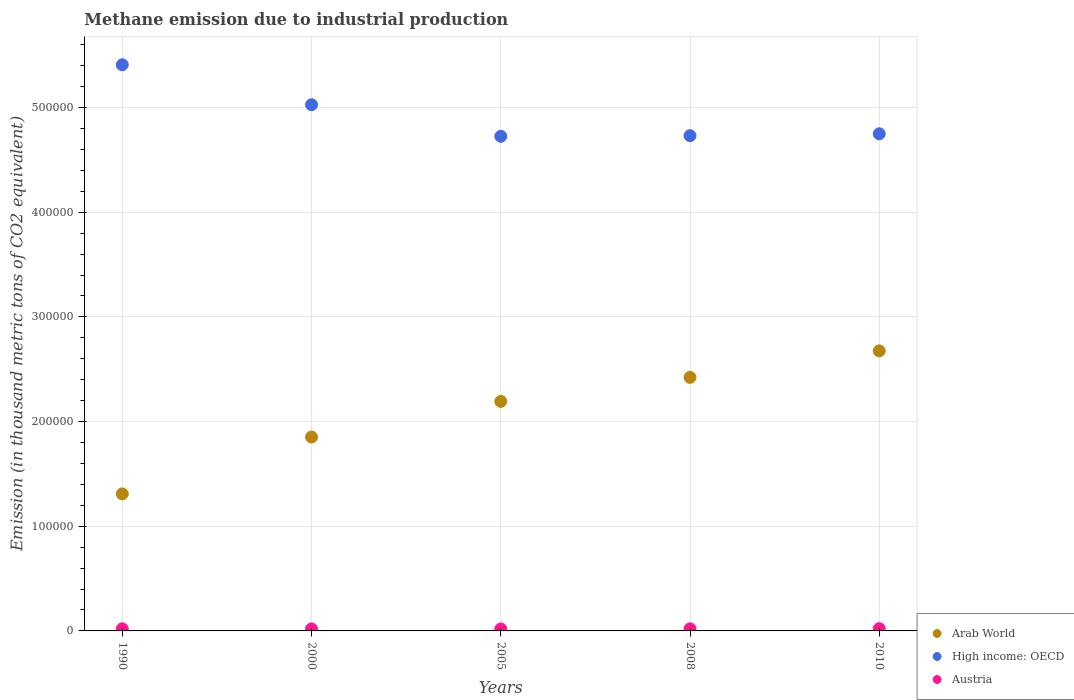How many different coloured dotlines are there?
Make the answer very short. 3. What is the amount of methane emitted in High income: OECD in 2008?
Provide a succinct answer. 4.73e+05. Across all years, what is the maximum amount of methane emitted in Austria?
Give a very brief answer. 2148.9. Across all years, what is the minimum amount of methane emitted in Arab World?
Your response must be concise. 1.31e+05. In which year was the amount of methane emitted in Austria minimum?
Ensure brevity in your answer.  2005. What is the total amount of methane emitted in High income: OECD in the graph?
Your response must be concise. 2.46e+06. What is the difference between the amount of methane emitted in Austria in 1990 and that in 2005?
Offer a very short reply. 182.3. What is the difference between the amount of methane emitted in High income: OECD in 2005 and the amount of methane emitted in Austria in 2008?
Your response must be concise. 4.71e+05. What is the average amount of methane emitted in Arab World per year?
Make the answer very short. 2.09e+05. In the year 2008, what is the difference between the amount of methane emitted in High income: OECD and amount of methane emitted in Arab World?
Ensure brevity in your answer.  2.31e+05. In how many years, is the amount of methane emitted in High income: OECD greater than 60000 thousand metric tons?
Keep it short and to the point. 5. What is the ratio of the amount of methane emitted in Austria in 1990 to that in 2008?
Offer a terse response. 1. Is the difference between the amount of methane emitted in High income: OECD in 1990 and 2008 greater than the difference between the amount of methane emitted in Arab World in 1990 and 2008?
Provide a short and direct response. Yes. What is the difference between the highest and the second highest amount of methane emitted in Austria?
Offer a very short reply. 118.3. What is the difference between the highest and the lowest amount of methane emitted in Austria?
Provide a succinct answer. 300.6. In how many years, is the amount of methane emitted in Arab World greater than the average amount of methane emitted in Arab World taken over all years?
Your response must be concise. 3. Is the sum of the amount of methane emitted in Arab World in 1990 and 2005 greater than the maximum amount of methane emitted in High income: OECD across all years?
Provide a short and direct response. No. Does the amount of methane emitted in High income: OECD monotonically increase over the years?
Provide a succinct answer. No. Is the amount of methane emitted in Arab World strictly greater than the amount of methane emitted in High income: OECD over the years?
Make the answer very short. No. How many dotlines are there?
Provide a succinct answer. 3. What is the difference between two consecutive major ticks on the Y-axis?
Offer a very short reply. 1.00e+05. Are the values on the major ticks of Y-axis written in scientific E-notation?
Provide a succinct answer. No. Does the graph contain any zero values?
Provide a short and direct response. No. Where does the legend appear in the graph?
Provide a short and direct response. Bottom right. How are the legend labels stacked?
Your answer should be compact. Vertical. What is the title of the graph?
Ensure brevity in your answer.  Methane emission due to industrial production. What is the label or title of the Y-axis?
Offer a terse response. Emission (in thousand metric tons of CO2 equivalent). What is the Emission (in thousand metric tons of CO2 equivalent) of Arab World in 1990?
Offer a very short reply. 1.31e+05. What is the Emission (in thousand metric tons of CO2 equivalent) in High income: OECD in 1990?
Ensure brevity in your answer.  5.41e+05. What is the Emission (in thousand metric tons of CO2 equivalent) in Austria in 1990?
Keep it short and to the point. 2030.6. What is the Emission (in thousand metric tons of CO2 equivalent) in Arab World in 2000?
Make the answer very short. 1.85e+05. What is the Emission (in thousand metric tons of CO2 equivalent) of High income: OECD in 2000?
Offer a terse response. 5.03e+05. What is the Emission (in thousand metric tons of CO2 equivalent) of Austria in 2000?
Offer a terse response. 1944.7. What is the Emission (in thousand metric tons of CO2 equivalent) of Arab World in 2005?
Offer a terse response. 2.19e+05. What is the Emission (in thousand metric tons of CO2 equivalent) in High income: OECD in 2005?
Provide a succinct answer. 4.73e+05. What is the Emission (in thousand metric tons of CO2 equivalent) in Austria in 2005?
Offer a very short reply. 1848.3. What is the Emission (in thousand metric tons of CO2 equivalent) in Arab World in 2008?
Ensure brevity in your answer.  2.42e+05. What is the Emission (in thousand metric tons of CO2 equivalent) in High income: OECD in 2008?
Your response must be concise. 4.73e+05. What is the Emission (in thousand metric tons of CO2 equivalent) of Austria in 2008?
Keep it short and to the point. 2025.8. What is the Emission (in thousand metric tons of CO2 equivalent) of Arab World in 2010?
Provide a succinct answer. 2.68e+05. What is the Emission (in thousand metric tons of CO2 equivalent) in High income: OECD in 2010?
Offer a very short reply. 4.75e+05. What is the Emission (in thousand metric tons of CO2 equivalent) in Austria in 2010?
Keep it short and to the point. 2148.9. Across all years, what is the maximum Emission (in thousand metric tons of CO2 equivalent) in Arab World?
Offer a terse response. 2.68e+05. Across all years, what is the maximum Emission (in thousand metric tons of CO2 equivalent) of High income: OECD?
Provide a short and direct response. 5.41e+05. Across all years, what is the maximum Emission (in thousand metric tons of CO2 equivalent) of Austria?
Your answer should be compact. 2148.9. Across all years, what is the minimum Emission (in thousand metric tons of CO2 equivalent) of Arab World?
Offer a terse response. 1.31e+05. Across all years, what is the minimum Emission (in thousand metric tons of CO2 equivalent) of High income: OECD?
Ensure brevity in your answer.  4.73e+05. Across all years, what is the minimum Emission (in thousand metric tons of CO2 equivalent) in Austria?
Offer a very short reply. 1848.3. What is the total Emission (in thousand metric tons of CO2 equivalent) of Arab World in the graph?
Your response must be concise. 1.05e+06. What is the total Emission (in thousand metric tons of CO2 equivalent) in High income: OECD in the graph?
Ensure brevity in your answer.  2.46e+06. What is the total Emission (in thousand metric tons of CO2 equivalent) of Austria in the graph?
Keep it short and to the point. 9998.3. What is the difference between the Emission (in thousand metric tons of CO2 equivalent) in Arab World in 1990 and that in 2000?
Give a very brief answer. -5.43e+04. What is the difference between the Emission (in thousand metric tons of CO2 equivalent) of High income: OECD in 1990 and that in 2000?
Give a very brief answer. 3.82e+04. What is the difference between the Emission (in thousand metric tons of CO2 equivalent) in Austria in 1990 and that in 2000?
Make the answer very short. 85.9. What is the difference between the Emission (in thousand metric tons of CO2 equivalent) in Arab World in 1990 and that in 2005?
Make the answer very short. -8.84e+04. What is the difference between the Emission (in thousand metric tons of CO2 equivalent) in High income: OECD in 1990 and that in 2005?
Offer a terse response. 6.83e+04. What is the difference between the Emission (in thousand metric tons of CO2 equivalent) in Austria in 1990 and that in 2005?
Your answer should be compact. 182.3. What is the difference between the Emission (in thousand metric tons of CO2 equivalent) of Arab World in 1990 and that in 2008?
Offer a terse response. -1.11e+05. What is the difference between the Emission (in thousand metric tons of CO2 equivalent) in High income: OECD in 1990 and that in 2008?
Ensure brevity in your answer.  6.77e+04. What is the difference between the Emission (in thousand metric tons of CO2 equivalent) of Austria in 1990 and that in 2008?
Your answer should be very brief. 4.8. What is the difference between the Emission (in thousand metric tons of CO2 equivalent) of Arab World in 1990 and that in 2010?
Give a very brief answer. -1.37e+05. What is the difference between the Emission (in thousand metric tons of CO2 equivalent) in High income: OECD in 1990 and that in 2010?
Offer a terse response. 6.59e+04. What is the difference between the Emission (in thousand metric tons of CO2 equivalent) of Austria in 1990 and that in 2010?
Ensure brevity in your answer.  -118.3. What is the difference between the Emission (in thousand metric tons of CO2 equivalent) of Arab World in 2000 and that in 2005?
Offer a very short reply. -3.41e+04. What is the difference between the Emission (in thousand metric tons of CO2 equivalent) of High income: OECD in 2000 and that in 2005?
Make the answer very short. 3.02e+04. What is the difference between the Emission (in thousand metric tons of CO2 equivalent) of Austria in 2000 and that in 2005?
Give a very brief answer. 96.4. What is the difference between the Emission (in thousand metric tons of CO2 equivalent) of Arab World in 2000 and that in 2008?
Keep it short and to the point. -5.70e+04. What is the difference between the Emission (in thousand metric tons of CO2 equivalent) in High income: OECD in 2000 and that in 2008?
Make the answer very short. 2.96e+04. What is the difference between the Emission (in thousand metric tons of CO2 equivalent) in Austria in 2000 and that in 2008?
Give a very brief answer. -81.1. What is the difference between the Emission (in thousand metric tons of CO2 equivalent) of Arab World in 2000 and that in 2010?
Ensure brevity in your answer.  -8.23e+04. What is the difference between the Emission (in thousand metric tons of CO2 equivalent) in High income: OECD in 2000 and that in 2010?
Keep it short and to the point. 2.78e+04. What is the difference between the Emission (in thousand metric tons of CO2 equivalent) in Austria in 2000 and that in 2010?
Your response must be concise. -204.2. What is the difference between the Emission (in thousand metric tons of CO2 equivalent) of Arab World in 2005 and that in 2008?
Your response must be concise. -2.29e+04. What is the difference between the Emission (in thousand metric tons of CO2 equivalent) of High income: OECD in 2005 and that in 2008?
Ensure brevity in your answer.  -593. What is the difference between the Emission (in thousand metric tons of CO2 equivalent) of Austria in 2005 and that in 2008?
Offer a very short reply. -177.5. What is the difference between the Emission (in thousand metric tons of CO2 equivalent) in Arab World in 2005 and that in 2010?
Your answer should be very brief. -4.82e+04. What is the difference between the Emission (in thousand metric tons of CO2 equivalent) of High income: OECD in 2005 and that in 2010?
Your answer should be very brief. -2407.6. What is the difference between the Emission (in thousand metric tons of CO2 equivalent) of Austria in 2005 and that in 2010?
Your answer should be very brief. -300.6. What is the difference between the Emission (in thousand metric tons of CO2 equivalent) in Arab World in 2008 and that in 2010?
Make the answer very short. -2.53e+04. What is the difference between the Emission (in thousand metric tons of CO2 equivalent) of High income: OECD in 2008 and that in 2010?
Give a very brief answer. -1814.6. What is the difference between the Emission (in thousand metric tons of CO2 equivalent) in Austria in 2008 and that in 2010?
Keep it short and to the point. -123.1. What is the difference between the Emission (in thousand metric tons of CO2 equivalent) in Arab World in 1990 and the Emission (in thousand metric tons of CO2 equivalent) in High income: OECD in 2000?
Offer a very short reply. -3.72e+05. What is the difference between the Emission (in thousand metric tons of CO2 equivalent) of Arab World in 1990 and the Emission (in thousand metric tons of CO2 equivalent) of Austria in 2000?
Offer a terse response. 1.29e+05. What is the difference between the Emission (in thousand metric tons of CO2 equivalent) in High income: OECD in 1990 and the Emission (in thousand metric tons of CO2 equivalent) in Austria in 2000?
Your answer should be compact. 5.39e+05. What is the difference between the Emission (in thousand metric tons of CO2 equivalent) in Arab World in 1990 and the Emission (in thousand metric tons of CO2 equivalent) in High income: OECD in 2005?
Your answer should be very brief. -3.42e+05. What is the difference between the Emission (in thousand metric tons of CO2 equivalent) in Arab World in 1990 and the Emission (in thousand metric tons of CO2 equivalent) in Austria in 2005?
Keep it short and to the point. 1.29e+05. What is the difference between the Emission (in thousand metric tons of CO2 equivalent) of High income: OECD in 1990 and the Emission (in thousand metric tons of CO2 equivalent) of Austria in 2005?
Your answer should be very brief. 5.39e+05. What is the difference between the Emission (in thousand metric tons of CO2 equivalent) in Arab World in 1990 and the Emission (in thousand metric tons of CO2 equivalent) in High income: OECD in 2008?
Ensure brevity in your answer.  -3.42e+05. What is the difference between the Emission (in thousand metric tons of CO2 equivalent) of Arab World in 1990 and the Emission (in thousand metric tons of CO2 equivalent) of Austria in 2008?
Offer a terse response. 1.29e+05. What is the difference between the Emission (in thousand metric tons of CO2 equivalent) of High income: OECD in 1990 and the Emission (in thousand metric tons of CO2 equivalent) of Austria in 2008?
Make the answer very short. 5.39e+05. What is the difference between the Emission (in thousand metric tons of CO2 equivalent) in Arab World in 1990 and the Emission (in thousand metric tons of CO2 equivalent) in High income: OECD in 2010?
Your answer should be compact. -3.44e+05. What is the difference between the Emission (in thousand metric tons of CO2 equivalent) in Arab World in 1990 and the Emission (in thousand metric tons of CO2 equivalent) in Austria in 2010?
Offer a terse response. 1.29e+05. What is the difference between the Emission (in thousand metric tons of CO2 equivalent) of High income: OECD in 1990 and the Emission (in thousand metric tons of CO2 equivalent) of Austria in 2010?
Offer a very short reply. 5.39e+05. What is the difference between the Emission (in thousand metric tons of CO2 equivalent) of Arab World in 2000 and the Emission (in thousand metric tons of CO2 equivalent) of High income: OECD in 2005?
Provide a short and direct response. -2.87e+05. What is the difference between the Emission (in thousand metric tons of CO2 equivalent) of Arab World in 2000 and the Emission (in thousand metric tons of CO2 equivalent) of Austria in 2005?
Give a very brief answer. 1.83e+05. What is the difference between the Emission (in thousand metric tons of CO2 equivalent) of High income: OECD in 2000 and the Emission (in thousand metric tons of CO2 equivalent) of Austria in 2005?
Give a very brief answer. 5.01e+05. What is the difference between the Emission (in thousand metric tons of CO2 equivalent) in Arab World in 2000 and the Emission (in thousand metric tons of CO2 equivalent) in High income: OECD in 2008?
Your response must be concise. -2.88e+05. What is the difference between the Emission (in thousand metric tons of CO2 equivalent) in Arab World in 2000 and the Emission (in thousand metric tons of CO2 equivalent) in Austria in 2008?
Offer a terse response. 1.83e+05. What is the difference between the Emission (in thousand metric tons of CO2 equivalent) in High income: OECD in 2000 and the Emission (in thousand metric tons of CO2 equivalent) in Austria in 2008?
Offer a very short reply. 5.01e+05. What is the difference between the Emission (in thousand metric tons of CO2 equivalent) of Arab World in 2000 and the Emission (in thousand metric tons of CO2 equivalent) of High income: OECD in 2010?
Offer a very short reply. -2.90e+05. What is the difference between the Emission (in thousand metric tons of CO2 equivalent) of Arab World in 2000 and the Emission (in thousand metric tons of CO2 equivalent) of Austria in 2010?
Your response must be concise. 1.83e+05. What is the difference between the Emission (in thousand metric tons of CO2 equivalent) of High income: OECD in 2000 and the Emission (in thousand metric tons of CO2 equivalent) of Austria in 2010?
Give a very brief answer. 5.01e+05. What is the difference between the Emission (in thousand metric tons of CO2 equivalent) in Arab World in 2005 and the Emission (in thousand metric tons of CO2 equivalent) in High income: OECD in 2008?
Your answer should be very brief. -2.54e+05. What is the difference between the Emission (in thousand metric tons of CO2 equivalent) in Arab World in 2005 and the Emission (in thousand metric tons of CO2 equivalent) in Austria in 2008?
Offer a very short reply. 2.17e+05. What is the difference between the Emission (in thousand metric tons of CO2 equivalent) of High income: OECD in 2005 and the Emission (in thousand metric tons of CO2 equivalent) of Austria in 2008?
Your response must be concise. 4.71e+05. What is the difference between the Emission (in thousand metric tons of CO2 equivalent) in Arab World in 2005 and the Emission (in thousand metric tons of CO2 equivalent) in High income: OECD in 2010?
Ensure brevity in your answer.  -2.56e+05. What is the difference between the Emission (in thousand metric tons of CO2 equivalent) in Arab World in 2005 and the Emission (in thousand metric tons of CO2 equivalent) in Austria in 2010?
Your response must be concise. 2.17e+05. What is the difference between the Emission (in thousand metric tons of CO2 equivalent) of High income: OECD in 2005 and the Emission (in thousand metric tons of CO2 equivalent) of Austria in 2010?
Keep it short and to the point. 4.70e+05. What is the difference between the Emission (in thousand metric tons of CO2 equivalent) in Arab World in 2008 and the Emission (in thousand metric tons of CO2 equivalent) in High income: OECD in 2010?
Make the answer very short. -2.33e+05. What is the difference between the Emission (in thousand metric tons of CO2 equivalent) in Arab World in 2008 and the Emission (in thousand metric tons of CO2 equivalent) in Austria in 2010?
Your answer should be very brief. 2.40e+05. What is the difference between the Emission (in thousand metric tons of CO2 equivalent) of High income: OECD in 2008 and the Emission (in thousand metric tons of CO2 equivalent) of Austria in 2010?
Keep it short and to the point. 4.71e+05. What is the average Emission (in thousand metric tons of CO2 equivalent) of Arab World per year?
Keep it short and to the point. 2.09e+05. What is the average Emission (in thousand metric tons of CO2 equivalent) in High income: OECD per year?
Provide a succinct answer. 4.93e+05. What is the average Emission (in thousand metric tons of CO2 equivalent) in Austria per year?
Offer a very short reply. 1999.66. In the year 1990, what is the difference between the Emission (in thousand metric tons of CO2 equivalent) of Arab World and Emission (in thousand metric tons of CO2 equivalent) of High income: OECD?
Offer a very short reply. -4.10e+05. In the year 1990, what is the difference between the Emission (in thousand metric tons of CO2 equivalent) of Arab World and Emission (in thousand metric tons of CO2 equivalent) of Austria?
Give a very brief answer. 1.29e+05. In the year 1990, what is the difference between the Emission (in thousand metric tons of CO2 equivalent) of High income: OECD and Emission (in thousand metric tons of CO2 equivalent) of Austria?
Your response must be concise. 5.39e+05. In the year 2000, what is the difference between the Emission (in thousand metric tons of CO2 equivalent) of Arab World and Emission (in thousand metric tons of CO2 equivalent) of High income: OECD?
Your response must be concise. -3.17e+05. In the year 2000, what is the difference between the Emission (in thousand metric tons of CO2 equivalent) of Arab World and Emission (in thousand metric tons of CO2 equivalent) of Austria?
Give a very brief answer. 1.83e+05. In the year 2000, what is the difference between the Emission (in thousand metric tons of CO2 equivalent) of High income: OECD and Emission (in thousand metric tons of CO2 equivalent) of Austria?
Offer a very short reply. 5.01e+05. In the year 2005, what is the difference between the Emission (in thousand metric tons of CO2 equivalent) of Arab World and Emission (in thousand metric tons of CO2 equivalent) of High income: OECD?
Provide a short and direct response. -2.53e+05. In the year 2005, what is the difference between the Emission (in thousand metric tons of CO2 equivalent) of Arab World and Emission (in thousand metric tons of CO2 equivalent) of Austria?
Your response must be concise. 2.17e+05. In the year 2005, what is the difference between the Emission (in thousand metric tons of CO2 equivalent) of High income: OECD and Emission (in thousand metric tons of CO2 equivalent) of Austria?
Provide a short and direct response. 4.71e+05. In the year 2008, what is the difference between the Emission (in thousand metric tons of CO2 equivalent) in Arab World and Emission (in thousand metric tons of CO2 equivalent) in High income: OECD?
Give a very brief answer. -2.31e+05. In the year 2008, what is the difference between the Emission (in thousand metric tons of CO2 equivalent) of Arab World and Emission (in thousand metric tons of CO2 equivalent) of Austria?
Make the answer very short. 2.40e+05. In the year 2008, what is the difference between the Emission (in thousand metric tons of CO2 equivalent) of High income: OECD and Emission (in thousand metric tons of CO2 equivalent) of Austria?
Ensure brevity in your answer.  4.71e+05. In the year 2010, what is the difference between the Emission (in thousand metric tons of CO2 equivalent) in Arab World and Emission (in thousand metric tons of CO2 equivalent) in High income: OECD?
Your answer should be very brief. -2.07e+05. In the year 2010, what is the difference between the Emission (in thousand metric tons of CO2 equivalent) of Arab World and Emission (in thousand metric tons of CO2 equivalent) of Austria?
Your answer should be very brief. 2.65e+05. In the year 2010, what is the difference between the Emission (in thousand metric tons of CO2 equivalent) in High income: OECD and Emission (in thousand metric tons of CO2 equivalent) in Austria?
Offer a terse response. 4.73e+05. What is the ratio of the Emission (in thousand metric tons of CO2 equivalent) in Arab World in 1990 to that in 2000?
Keep it short and to the point. 0.71. What is the ratio of the Emission (in thousand metric tons of CO2 equivalent) in High income: OECD in 1990 to that in 2000?
Your response must be concise. 1.08. What is the ratio of the Emission (in thousand metric tons of CO2 equivalent) in Austria in 1990 to that in 2000?
Provide a succinct answer. 1.04. What is the ratio of the Emission (in thousand metric tons of CO2 equivalent) of Arab World in 1990 to that in 2005?
Ensure brevity in your answer.  0.6. What is the ratio of the Emission (in thousand metric tons of CO2 equivalent) of High income: OECD in 1990 to that in 2005?
Make the answer very short. 1.14. What is the ratio of the Emission (in thousand metric tons of CO2 equivalent) of Austria in 1990 to that in 2005?
Provide a short and direct response. 1.1. What is the ratio of the Emission (in thousand metric tons of CO2 equivalent) of Arab World in 1990 to that in 2008?
Offer a terse response. 0.54. What is the ratio of the Emission (in thousand metric tons of CO2 equivalent) in High income: OECD in 1990 to that in 2008?
Your answer should be very brief. 1.14. What is the ratio of the Emission (in thousand metric tons of CO2 equivalent) in Austria in 1990 to that in 2008?
Provide a succinct answer. 1. What is the ratio of the Emission (in thousand metric tons of CO2 equivalent) in Arab World in 1990 to that in 2010?
Offer a very short reply. 0.49. What is the ratio of the Emission (in thousand metric tons of CO2 equivalent) in High income: OECD in 1990 to that in 2010?
Offer a terse response. 1.14. What is the ratio of the Emission (in thousand metric tons of CO2 equivalent) in Austria in 1990 to that in 2010?
Your response must be concise. 0.94. What is the ratio of the Emission (in thousand metric tons of CO2 equivalent) of Arab World in 2000 to that in 2005?
Offer a terse response. 0.84. What is the ratio of the Emission (in thousand metric tons of CO2 equivalent) of High income: OECD in 2000 to that in 2005?
Provide a short and direct response. 1.06. What is the ratio of the Emission (in thousand metric tons of CO2 equivalent) in Austria in 2000 to that in 2005?
Your response must be concise. 1.05. What is the ratio of the Emission (in thousand metric tons of CO2 equivalent) of Arab World in 2000 to that in 2008?
Provide a succinct answer. 0.76. What is the ratio of the Emission (in thousand metric tons of CO2 equivalent) of Austria in 2000 to that in 2008?
Your response must be concise. 0.96. What is the ratio of the Emission (in thousand metric tons of CO2 equivalent) of Arab World in 2000 to that in 2010?
Offer a very short reply. 0.69. What is the ratio of the Emission (in thousand metric tons of CO2 equivalent) in High income: OECD in 2000 to that in 2010?
Ensure brevity in your answer.  1.06. What is the ratio of the Emission (in thousand metric tons of CO2 equivalent) in Austria in 2000 to that in 2010?
Make the answer very short. 0.91. What is the ratio of the Emission (in thousand metric tons of CO2 equivalent) in Arab World in 2005 to that in 2008?
Offer a very short reply. 0.91. What is the ratio of the Emission (in thousand metric tons of CO2 equivalent) of Austria in 2005 to that in 2008?
Provide a short and direct response. 0.91. What is the ratio of the Emission (in thousand metric tons of CO2 equivalent) in Arab World in 2005 to that in 2010?
Offer a terse response. 0.82. What is the ratio of the Emission (in thousand metric tons of CO2 equivalent) in Austria in 2005 to that in 2010?
Offer a terse response. 0.86. What is the ratio of the Emission (in thousand metric tons of CO2 equivalent) in Arab World in 2008 to that in 2010?
Your answer should be compact. 0.91. What is the ratio of the Emission (in thousand metric tons of CO2 equivalent) in Austria in 2008 to that in 2010?
Provide a succinct answer. 0.94. What is the difference between the highest and the second highest Emission (in thousand metric tons of CO2 equivalent) of Arab World?
Ensure brevity in your answer.  2.53e+04. What is the difference between the highest and the second highest Emission (in thousand metric tons of CO2 equivalent) in High income: OECD?
Provide a short and direct response. 3.82e+04. What is the difference between the highest and the second highest Emission (in thousand metric tons of CO2 equivalent) of Austria?
Provide a succinct answer. 118.3. What is the difference between the highest and the lowest Emission (in thousand metric tons of CO2 equivalent) in Arab World?
Your response must be concise. 1.37e+05. What is the difference between the highest and the lowest Emission (in thousand metric tons of CO2 equivalent) in High income: OECD?
Make the answer very short. 6.83e+04. What is the difference between the highest and the lowest Emission (in thousand metric tons of CO2 equivalent) in Austria?
Keep it short and to the point. 300.6. 